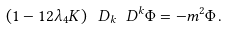Convert formula to latex. <formula><loc_0><loc_0><loc_500><loc_500>\left ( 1 - 1 2 \lambda _ { 4 } K \right ) \ D _ { k } \ D ^ { k } { \Phi } = - m ^ { 2 } { \Phi } \, .</formula> 